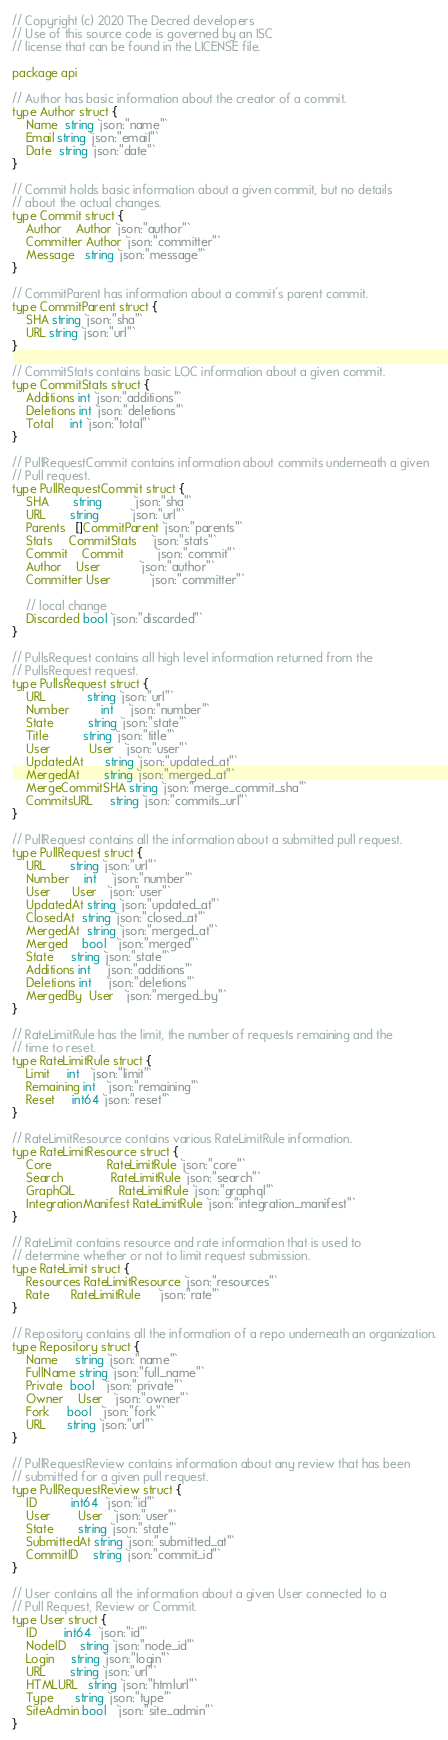Convert code to text. <code><loc_0><loc_0><loc_500><loc_500><_Go_>// Copyright (c) 2020 The Decred developers
// Use of this source code is governed by an ISC
// license that can be found in the LICENSE file.

package api

// Author has basic information about the creator of a commit.
type Author struct {
	Name  string `json:"name"`
	Email string `json:"email"`
	Date  string `json:"date"`
}

// Commit holds basic information about a given commit, but no details
// about the actual changes.
type Commit struct {
	Author    Author `json:"author"`
	Committer Author `json:"committer"`
	Message   string `json:"message"`
}

// CommitParent has information about a commit's parent commit.
type CommitParent struct {
	SHA string `json:"sha"`
	URL string `json:"url"`
}

// CommitStats contains basic LOC information about a given commit.
type CommitStats struct {
	Additions int `json:"additions"`
	Deletions int `json:"deletions"`
	Total     int `json:"total"`
}

// PullRequestCommit contains information about commits underneath a given
// Pull request.
type PullRequestCommit struct {
	SHA       string         `json:"sha"`
	URL       string         `json:"url"`
	Parents   []CommitParent `json:"parents"`
	Stats     CommitStats    `json:"stats"`
	Commit    Commit         `json:"commit"`
	Author    User           `json:"author"`
	Committer User           `json:"committer"`

	// local change
	Discarded bool `json:"discarded"`
}

// PullsRequest contains all high level information returned from the
// PullsRequest request.
type PullsRequest struct {
	URL            string `json:"url"`
	Number         int    `json:"number"`
	State          string `json:"state"`
	Title          string `json:"title"`
	User           User   `json:"user"`
	UpdatedAt      string `json:"updated_at"`
	MergedAt       string `json:"merged_at"`
	MergeCommitSHA string `json:"merge_commit_sha"`
	CommitsURL     string `json:"commits_url"`
}

// PullRequest contains all the information about a submitted pull request.
type PullRequest struct {
	URL       string `json:"url"`
	Number    int    `json:"number"`
	User      User   `json:"user"`
	UpdatedAt string `json:"updated_at"`
	ClosedAt  string `json:"closed_at"`
	MergedAt  string `json:"merged_at"`
	Merged    bool   `json:"merged"`
	State     string `json:"state"`
	Additions int    `json:"additions"`
	Deletions int    `json:"deletions"`
	MergedBy  User   `json:"merged_by"`
}

// RateLimitRule has the limit, the number of requests remaining and the
// time to reset.
type RateLimitRule struct {
	Limit     int   `json:"limit"`
	Remaining int   `json:"remaining"`
	Reset     int64 `json:"reset"`
}

// RateLimitResource contains various RateLimitRule information.
type RateLimitResource struct {
	Core                RateLimitRule `json:"core"`
	Search              RateLimitRule `json:"search"`
	GraphQL             RateLimitRule `json:"graphql"`
	IntegrationManifest RateLimitRule `json:"integration_manifest"`
}

// RateLimit contains resource and rate information that is used to
// determine whether or not to limit request submission.
type RateLimit struct {
	Resources RateLimitResource `json:"resources"`
	Rate      RateLimitRule     `json:"rate"`
}

// Repository contains all the information of a repo underneath an organization.
type Repository struct {
	Name     string `json:"name"`
	FullName string `json:"full_name"`
	Private  bool   `json:"private"`
	Owner    User   `json:"owner"`
	Fork     bool   `json:"fork"`
	URL      string `json:"url"`
}

// PullRequestReview contains information about any review that has been
// submitted for a given pull request.
type PullRequestReview struct {
	ID          int64  `json:"id"`
	User        User   `json:"user"`
	State       string `json:"state"`
	SubmittedAt string `json:"submitted_at"`
	CommitID    string `json:"commit_id"`
}

// User contains all the information about a given User connected to a
// Pull Request, Review or Commit.
type User struct {
	ID        int64  `json:"id"`
	NodeID    string `json:"node_id"`
	Login     string `json:"login"`
	URL       string `json:"url"`
	HTMLURL   string `json:"htmlurl"`
	Type      string `json:"type"`
	SiteAdmin bool   `json:"site_admin"`
}
</code> 